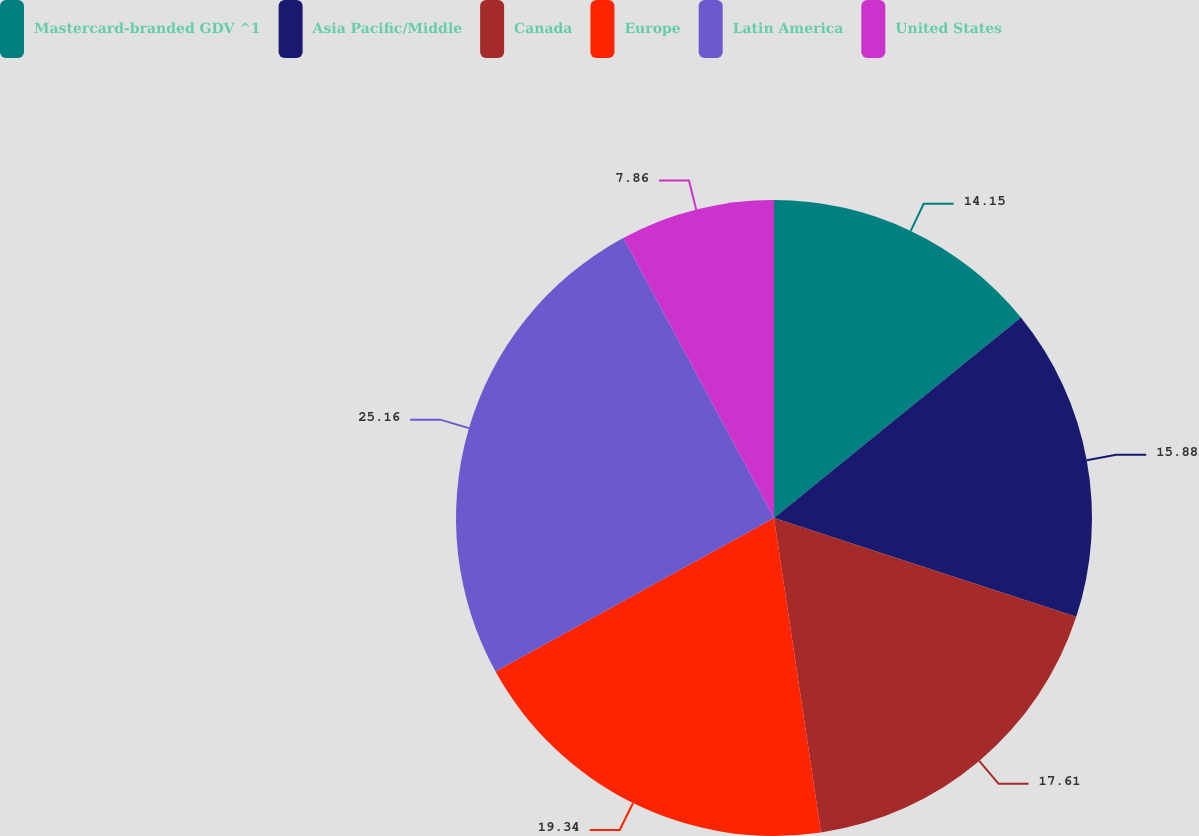Convert chart. <chart><loc_0><loc_0><loc_500><loc_500><pie_chart><fcel>Mastercard-branded GDV ^1<fcel>Asia Pacific/Middle<fcel>Canada<fcel>Europe<fcel>Latin America<fcel>United States<nl><fcel>14.15%<fcel>15.88%<fcel>17.61%<fcel>19.34%<fcel>25.16%<fcel>7.86%<nl></chart> 